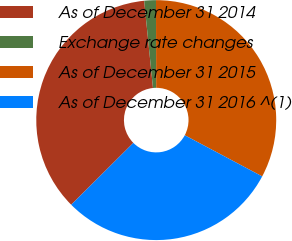Convert chart. <chart><loc_0><loc_0><loc_500><loc_500><pie_chart><fcel>As of December 31 2014<fcel>Exchange rate changes<fcel>As of December 31 2015<fcel>As of December 31 2016 ^(1)<nl><fcel>35.87%<fcel>1.57%<fcel>32.81%<fcel>29.76%<nl></chart> 